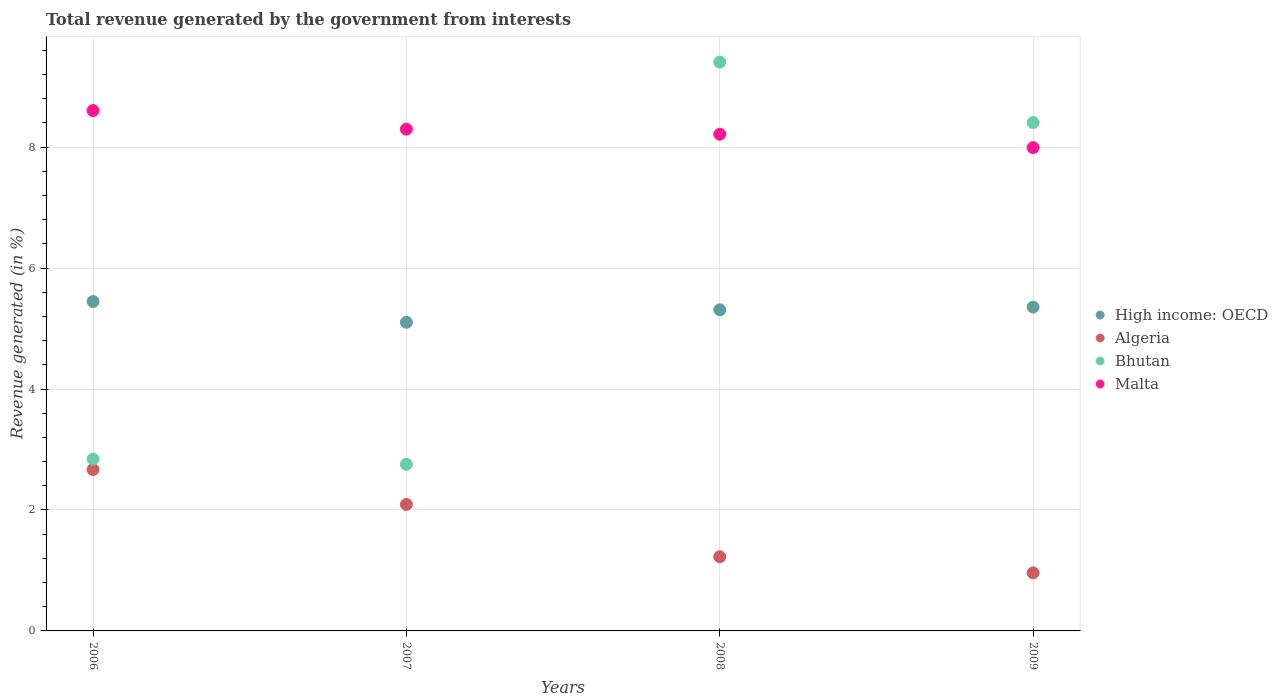Is the number of dotlines equal to the number of legend labels?
Provide a succinct answer. Yes. What is the total revenue generated in Malta in 2008?
Give a very brief answer. 8.21. Across all years, what is the maximum total revenue generated in High income: OECD?
Give a very brief answer. 5.45. Across all years, what is the minimum total revenue generated in Malta?
Offer a very short reply. 7.99. What is the total total revenue generated in Bhutan in the graph?
Give a very brief answer. 23.41. What is the difference between the total revenue generated in High income: OECD in 2007 and that in 2009?
Offer a terse response. -0.25. What is the difference between the total revenue generated in Algeria in 2009 and the total revenue generated in Bhutan in 2008?
Offer a terse response. -8.45. What is the average total revenue generated in Bhutan per year?
Ensure brevity in your answer.  5.85. In the year 2009, what is the difference between the total revenue generated in Algeria and total revenue generated in High income: OECD?
Your response must be concise. -4.39. What is the ratio of the total revenue generated in High income: OECD in 2006 to that in 2008?
Offer a terse response. 1.03. What is the difference between the highest and the second highest total revenue generated in Malta?
Ensure brevity in your answer.  0.31. What is the difference between the highest and the lowest total revenue generated in Malta?
Ensure brevity in your answer.  0.61. Is the sum of the total revenue generated in High income: OECD in 2007 and 2009 greater than the maximum total revenue generated in Malta across all years?
Give a very brief answer. Yes. Is it the case that in every year, the sum of the total revenue generated in High income: OECD and total revenue generated in Algeria  is greater than the sum of total revenue generated in Bhutan and total revenue generated in Malta?
Offer a very short reply. No. Is the total revenue generated in High income: OECD strictly greater than the total revenue generated in Algeria over the years?
Ensure brevity in your answer.  Yes. How many dotlines are there?
Give a very brief answer. 4. How many years are there in the graph?
Your answer should be compact. 4. What is the difference between two consecutive major ticks on the Y-axis?
Your answer should be compact. 2. Does the graph contain any zero values?
Keep it short and to the point. No. Does the graph contain grids?
Your answer should be compact. Yes. Where does the legend appear in the graph?
Your response must be concise. Center right. How are the legend labels stacked?
Your answer should be very brief. Vertical. What is the title of the graph?
Keep it short and to the point. Total revenue generated by the government from interests. Does "Fragile and conflict affected situations" appear as one of the legend labels in the graph?
Your answer should be very brief. No. What is the label or title of the Y-axis?
Make the answer very short. Revenue generated (in %). What is the Revenue generated (in %) in High income: OECD in 2006?
Your response must be concise. 5.45. What is the Revenue generated (in %) of Algeria in 2006?
Your answer should be compact. 2.67. What is the Revenue generated (in %) of Bhutan in 2006?
Your answer should be compact. 2.84. What is the Revenue generated (in %) in Malta in 2006?
Offer a very short reply. 8.6. What is the Revenue generated (in %) of High income: OECD in 2007?
Provide a succinct answer. 5.1. What is the Revenue generated (in %) in Algeria in 2007?
Provide a succinct answer. 2.09. What is the Revenue generated (in %) in Bhutan in 2007?
Give a very brief answer. 2.76. What is the Revenue generated (in %) of Malta in 2007?
Offer a terse response. 8.3. What is the Revenue generated (in %) in High income: OECD in 2008?
Provide a short and direct response. 5.31. What is the Revenue generated (in %) in Algeria in 2008?
Offer a terse response. 1.23. What is the Revenue generated (in %) in Bhutan in 2008?
Keep it short and to the point. 9.41. What is the Revenue generated (in %) of Malta in 2008?
Provide a succinct answer. 8.21. What is the Revenue generated (in %) of High income: OECD in 2009?
Your response must be concise. 5.35. What is the Revenue generated (in %) of Algeria in 2009?
Your answer should be very brief. 0.96. What is the Revenue generated (in %) of Bhutan in 2009?
Ensure brevity in your answer.  8.41. What is the Revenue generated (in %) of Malta in 2009?
Ensure brevity in your answer.  7.99. Across all years, what is the maximum Revenue generated (in %) of High income: OECD?
Your answer should be compact. 5.45. Across all years, what is the maximum Revenue generated (in %) of Algeria?
Make the answer very short. 2.67. Across all years, what is the maximum Revenue generated (in %) of Bhutan?
Make the answer very short. 9.41. Across all years, what is the maximum Revenue generated (in %) of Malta?
Provide a short and direct response. 8.6. Across all years, what is the minimum Revenue generated (in %) of High income: OECD?
Make the answer very short. 5.1. Across all years, what is the minimum Revenue generated (in %) of Algeria?
Give a very brief answer. 0.96. Across all years, what is the minimum Revenue generated (in %) in Bhutan?
Provide a short and direct response. 2.76. Across all years, what is the minimum Revenue generated (in %) in Malta?
Make the answer very short. 7.99. What is the total Revenue generated (in %) in High income: OECD in the graph?
Provide a short and direct response. 21.22. What is the total Revenue generated (in %) in Algeria in the graph?
Offer a terse response. 6.95. What is the total Revenue generated (in %) in Bhutan in the graph?
Offer a terse response. 23.41. What is the total Revenue generated (in %) of Malta in the graph?
Your response must be concise. 33.11. What is the difference between the Revenue generated (in %) in High income: OECD in 2006 and that in 2007?
Offer a terse response. 0.34. What is the difference between the Revenue generated (in %) in Algeria in 2006 and that in 2007?
Keep it short and to the point. 0.58. What is the difference between the Revenue generated (in %) in Bhutan in 2006 and that in 2007?
Your answer should be compact. 0.08. What is the difference between the Revenue generated (in %) of Malta in 2006 and that in 2007?
Make the answer very short. 0.31. What is the difference between the Revenue generated (in %) of High income: OECD in 2006 and that in 2008?
Ensure brevity in your answer.  0.14. What is the difference between the Revenue generated (in %) in Algeria in 2006 and that in 2008?
Make the answer very short. 1.44. What is the difference between the Revenue generated (in %) of Bhutan in 2006 and that in 2008?
Provide a short and direct response. -6.57. What is the difference between the Revenue generated (in %) in Malta in 2006 and that in 2008?
Your answer should be compact. 0.39. What is the difference between the Revenue generated (in %) of High income: OECD in 2006 and that in 2009?
Make the answer very short. 0.09. What is the difference between the Revenue generated (in %) in Algeria in 2006 and that in 2009?
Give a very brief answer. 1.71. What is the difference between the Revenue generated (in %) of Bhutan in 2006 and that in 2009?
Give a very brief answer. -5.57. What is the difference between the Revenue generated (in %) of Malta in 2006 and that in 2009?
Make the answer very short. 0.61. What is the difference between the Revenue generated (in %) of High income: OECD in 2007 and that in 2008?
Give a very brief answer. -0.21. What is the difference between the Revenue generated (in %) of Algeria in 2007 and that in 2008?
Make the answer very short. 0.86. What is the difference between the Revenue generated (in %) of Bhutan in 2007 and that in 2008?
Provide a short and direct response. -6.65. What is the difference between the Revenue generated (in %) in Malta in 2007 and that in 2008?
Provide a short and direct response. 0.08. What is the difference between the Revenue generated (in %) of High income: OECD in 2007 and that in 2009?
Keep it short and to the point. -0.25. What is the difference between the Revenue generated (in %) of Algeria in 2007 and that in 2009?
Offer a terse response. 1.13. What is the difference between the Revenue generated (in %) in Bhutan in 2007 and that in 2009?
Ensure brevity in your answer.  -5.65. What is the difference between the Revenue generated (in %) of Malta in 2007 and that in 2009?
Provide a succinct answer. 0.3. What is the difference between the Revenue generated (in %) in High income: OECD in 2008 and that in 2009?
Provide a succinct answer. -0.04. What is the difference between the Revenue generated (in %) of Algeria in 2008 and that in 2009?
Offer a terse response. 0.27. What is the difference between the Revenue generated (in %) of Malta in 2008 and that in 2009?
Make the answer very short. 0.22. What is the difference between the Revenue generated (in %) in High income: OECD in 2006 and the Revenue generated (in %) in Algeria in 2007?
Your response must be concise. 3.36. What is the difference between the Revenue generated (in %) in High income: OECD in 2006 and the Revenue generated (in %) in Bhutan in 2007?
Provide a succinct answer. 2.69. What is the difference between the Revenue generated (in %) of High income: OECD in 2006 and the Revenue generated (in %) of Malta in 2007?
Your response must be concise. -2.85. What is the difference between the Revenue generated (in %) in Algeria in 2006 and the Revenue generated (in %) in Bhutan in 2007?
Your response must be concise. -0.09. What is the difference between the Revenue generated (in %) in Algeria in 2006 and the Revenue generated (in %) in Malta in 2007?
Provide a succinct answer. -5.63. What is the difference between the Revenue generated (in %) in Bhutan in 2006 and the Revenue generated (in %) in Malta in 2007?
Offer a very short reply. -5.46. What is the difference between the Revenue generated (in %) in High income: OECD in 2006 and the Revenue generated (in %) in Algeria in 2008?
Your answer should be very brief. 4.22. What is the difference between the Revenue generated (in %) in High income: OECD in 2006 and the Revenue generated (in %) in Bhutan in 2008?
Your answer should be compact. -3.96. What is the difference between the Revenue generated (in %) in High income: OECD in 2006 and the Revenue generated (in %) in Malta in 2008?
Provide a succinct answer. -2.77. What is the difference between the Revenue generated (in %) of Algeria in 2006 and the Revenue generated (in %) of Bhutan in 2008?
Provide a succinct answer. -6.74. What is the difference between the Revenue generated (in %) in Algeria in 2006 and the Revenue generated (in %) in Malta in 2008?
Offer a terse response. -5.54. What is the difference between the Revenue generated (in %) of Bhutan in 2006 and the Revenue generated (in %) of Malta in 2008?
Ensure brevity in your answer.  -5.37. What is the difference between the Revenue generated (in %) of High income: OECD in 2006 and the Revenue generated (in %) of Algeria in 2009?
Make the answer very short. 4.49. What is the difference between the Revenue generated (in %) in High income: OECD in 2006 and the Revenue generated (in %) in Bhutan in 2009?
Ensure brevity in your answer.  -2.96. What is the difference between the Revenue generated (in %) of High income: OECD in 2006 and the Revenue generated (in %) of Malta in 2009?
Keep it short and to the point. -2.55. What is the difference between the Revenue generated (in %) in Algeria in 2006 and the Revenue generated (in %) in Bhutan in 2009?
Provide a short and direct response. -5.74. What is the difference between the Revenue generated (in %) of Algeria in 2006 and the Revenue generated (in %) of Malta in 2009?
Provide a succinct answer. -5.32. What is the difference between the Revenue generated (in %) of Bhutan in 2006 and the Revenue generated (in %) of Malta in 2009?
Your response must be concise. -5.15. What is the difference between the Revenue generated (in %) in High income: OECD in 2007 and the Revenue generated (in %) in Algeria in 2008?
Provide a succinct answer. 3.88. What is the difference between the Revenue generated (in %) in High income: OECD in 2007 and the Revenue generated (in %) in Bhutan in 2008?
Provide a short and direct response. -4.3. What is the difference between the Revenue generated (in %) in High income: OECD in 2007 and the Revenue generated (in %) in Malta in 2008?
Keep it short and to the point. -3.11. What is the difference between the Revenue generated (in %) in Algeria in 2007 and the Revenue generated (in %) in Bhutan in 2008?
Give a very brief answer. -7.32. What is the difference between the Revenue generated (in %) in Algeria in 2007 and the Revenue generated (in %) in Malta in 2008?
Ensure brevity in your answer.  -6.12. What is the difference between the Revenue generated (in %) of Bhutan in 2007 and the Revenue generated (in %) of Malta in 2008?
Provide a short and direct response. -5.46. What is the difference between the Revenue generated (in %) of High income: OECD in 2007 and the Revenue generated (in %) of Algeria in 2009?
Your answer should be very brief. 4.14. What is the difference between the Revenue generated (in %) of High income: OECD in 2007 and the Revenue generated (in %) of Bhutan in 2009?
Make the answer very short. -3.3. What is the difference between the Revenue generated (in %) in High income: OECD in 2007 and the Revenue generated (in %) in Malta in 2009?
Provide a short and direct response. -2.89. What is the difference between the Revenue generated (in %) in Algeria in 2007 and the Revenue generated (in %) in Bhutan in 2009?
Ensure brevity in your answer.  -6.32. What is the difference between the Revenue generated (in %) of Algeria in 2007 and the Revenue generated (in %) of Malta in 2009?
Your response must be concise. -5.9. What is the difference between the Revenue generated (in %) in Bhutan in 2007 and the Revenue generated (in %) in Malta in 2009?
Ensure brevity in your answer.  -5.24. What is the difference between the Revenue generated (in %) in High income: OECD in 2008 and the Revenue generated (in %) in Algeria in 2009?
Ensure brevity in your answer.  4.35. What is the difference between the Revenue generated (in %) in High income: OECD in 2008 and the Revenue generated (in %) in Bhutan in 2009?
Make the answer very short. -3.1. What is the difference between the Revenue generated (in %) in High income: OECD in 2008 and the Revenue generated (in %) in Malta in 2009?
Offer a terse response. -2.68. What is the difference between the Revenue generated (in %) of Algeria in 2008 and the Revenue generated (in %) of Bhutan in 2009?
Provide a succinct answer. -7.18. What is the difference between the Revenue generated (in %) in Algeria in 2008 and the Revenue generated (in %) in Malta in 2009?
Provide a succinct answer. -6.77. What is the difference between the Revenue generated (in %) of Bhutan in 2008 and the Revenue generated (in %) of Malta in 2009?
Give a very brief answer. 1.41. What is the average Revenue generated (in %) in High income: OECD per year?
Your answer should be compact. 5.3. What is the average Revenue generated (in %) of Algeria per year?
Your response must be concise. 1.74. What is the average Revenue generated (in %) of Bhutan per year?
Your answer should be very brief. 5.85. What is the average Revenue generated (in %) in Malta per year?
Provide a succinct answer. 8.28. In the year 2006, what is the difference between the Revenue generated (in %) of High income: OECD and Revenue generated (in %) of Algeria?
Make the answer very short. 2.78. In the year 2006, what is the difference between the Revenue generated (in %) in High income: OECD and Revenue generated (in %) in Bhutan?
Keep it short and to the point. 2.61. In the year 2006, what is the difference between the Revenue generated (in %) of High income: OECD and Revenue generated (in %) of Malta?
Give a very brief answer. -3.16. In the year 2006, what is the difference between the Revenue generated (in %) of Algeria and Revenue generated (in %) of Bhutan?
Offer a terse response. -0.17. In the year 2006, what is the difference between the Revenue generated (in %) of Algeria and Revenue generated (in %) of Malta?
Your answer should be compact. -5.94. In the year 2006, what is the difference between the Revenue generated (in %) of Bhutan and Revenue generated (in %) of Malta?
Ensure brevity in your answer.  -5.76. In the year 2007, what is the difference between the Revenue generated (in %) of High income: OECD and Revenue generated (in %) of Algeria?
Offer a terse response. 3.01. In the year 2007, what is the difference between the Revenue generated (in %) of High income: OECD and Revenue generated (in %) of Bhutan?
Your response must be concise. 2.35. In the year 2007, what is the difference between the Revenue generated (in %) of High income: OECD and Revenue generated (in %) of Malta?
Offer a very short reply. -3.19. In the year 2007, what is the difference between the Revenue generated (in %) of Algeria and Revenue generated (in %) of Bhutan?
Provide a succinct answer. -0.67. In the year 2007, what is the difference between the Revenue generated (in %) in Algeria and Revenue generated (in %) in Malta?
Your response must be concise. -6.21. In the year 2007, what is the difference between the Revenue generated (in %) in Bhutan and Revenue generated (in %) in Malta?
Your answer should be compact. -5.54. In the year 2008, what is the difference between the Revenue generated (in %) of High income: OECD and Revenue generated (in %) of Algeria?
Your answer should be very brief. 4.08. In the year 2008, what is the difference between the Revenue generated (in %) of High income: OECD and Revenue generated (in %) of Bhutan?
Provide a succinct answer. -4.1. In the year 2008, what is the difference between the Revenue generated (in %) in High income: OECD and Revenue generated (in %) in Malta?
Provide a short and direct response. -2.9. In the year 2008, what is the difference between the Revenue generated (in %) of Algeria and Revenue generated (in %) of Bhutan?
Your response must be concise. -8.18. In the year 2008, what is the difference between the Revenue generated (in %) in Algeria and Revenue generated (in %) in Malta?
Offer a terse response. -6.99. In the year 2008, what is the difference between the Revenue generated (in %) in Bhutan and Revenue generated (in %) in Malta?
Your answer should be very brief. 1.19. In the year 2009, what is the difference between the Revenue generated (in %) of High income: OECD and Revenue generated (in %) of Algeria?
Your response must be concise. 4.39. In the year 2009, what is the difference between the Revenue generated (in %) in High income: OECD and Revenue generated (in %) in Bhutan?
Your answer should be compact. -3.05. In the year 2009, what is the difference between the Revenue generated (in %) in High income: OECD and Revenue generated (in %) in Malta?
Provide a short and direct response. -2.64. In the year 2009, what is the difference between the Revenue generated (in %) of Algeria and Revenue generated (in %) of Bhutan?
Provide a short and direct response. -7.45. In the year 2009, what is the difference between the Revenue generated (in %) of Algeria and Revenue generated (in %) of Malta?
Your response must be concise. -7.03. In the year 2009, what is the difference between the Revenue generated (in %) in Bhutan and Revenue generated (in %) in Malta?
Your answer should be very brief. 0.41. What is the ratio of the Revenue generated (in %) of High income: OECD in 2006 to that in 2007?
Offer a very short reply. 1.07. What is the ratio of the Revenue generated (in %) in Algeria in 2006 to that in 2007?
Provide a short and direct response. 1.28. What is the ratio of the Revenue generated (in %) of Bhutan in 2006 to that in 2007?
Offer a terse response. 1.03. What is the ratio of the Revenue generated (in %) in Malta in 2006 to that in 2007?
Ensure brevity in your answer.  1.04. What is the ratio of the Revenue generated (in %) of High income: OECD in 2006 to that in 2008?
Offer a terse response. 1.03. What is the ratio of the Revenue generated (in %) of Algeria in 2006 to that in 2008?
Your response must be concise. 2.18. What is the ratio of the Revenue generated (in %) of Bhutan in 2006 to that in 2008?
Your response must be concise. 0.3. What is the ratio of the Revenue generated (in %) in Malta in 2006 to that in 2008?
Offer a very short reply. 1.05. What is the ratio of the Revenue generated (in %) in High income: OECD in 2006 to that in 2009?
Your answer should be very brief. 1.02. What is the ratio of the Revenue generated (in %) in Algeria in 2006 to that in 2009?
Your answer should be very brief. 2.78. What is the ratio of the Revenue generated (in %) of Bhutan in 2006 to that in 2009?
Your answer should be very brief. 0.34. What is the ratio of the Revenue generated (in %) in Malta in 2006 to that in 2009?
Make the answer very short. 1.08. What is the ratio of the Revenue generated (in %) of High income: OECD in 2007 to that in 2008?
Your response must be concise. 0.96. What is the ratio of the Revenue generated (in %) of Algeria in 2007 to that in 2008?
Make the answer very short. 1.71. What is the ratio of the Revenue generated (in %) in Bhutan in 2007 to that in 2008?
Your answer should be very brief. 0.29. What is the ratio of the Revenue generated (in %) of Malta in 2007 to that in 2008?
Ensure brevity in your answer.  1.01. What is the ratio of the Revenue generated (in %) in High income: OECD in 2007 to that in 2009?
Ensure brevity in your answer.  0.95. What is the ratio of the Revenue generated (in %) in Algeria in 2007 to that in 2009?
Keep it short and to the point. 2.18. What is the ratio of the Revenue generated (in %) in Bhutan in 2007 to that in 2009?
Make the answer very short. 0.33. What is the ratio of the Revenue generated (in %) of Malta in 2007 to that in 2009?
Your answer should be compact. 1.04. What is the ratio of the Revenue generated (in %) in High income: OECD in 2008 to that in 2009?
Provide a succinct answer. 0.99. What is the ratio of the Revenue generated (in %) of Algeria in 2008 to that in 2009?
Provide a succinct answer. 1.28. What is the ratio of the Revenue generated (in %) in Bhutan in 2008 to that in 2009?
Provide a short and direct response. 1.12. What is the ratio of the Revenue generated (in %) in Malta in 2008 to that in 2009?
Your answer should be very brief. 1.03. What is the difference between the highest and the second highest Revenue generated (in %) of High income: OECD?
Offer a terse response. 0.09. What is the difference between the highest and the second highest Revenue generated (in %) of Algeria?
Offer a terse response. 0.58. What is the difference between the highest and the second highest Revenue generated (in %) in Bhutan?
Offer a very short reply. 1. What is the difference between the highest and the second highest Revenue generated (in %) in Malta?
Give a very brief answer. 0.31. What is the difference between the highest and the lowest Revenue generated (in %) in High income: OECD?
Offer a very short reply. 0.34. What is the difference between the highest and the lowest Revenue generated (in %) in Algeria?
Ensure brevity in your answer.  1.71. What is the difference between the highest and the lowest Revenue generated (in %) in Bhutan?
Ensure brevity in your answer.  6.65. What is the difference between the highest and the lowest Revenue generated (in %) of Malta?
Provide a succinct answer. 0.61. 